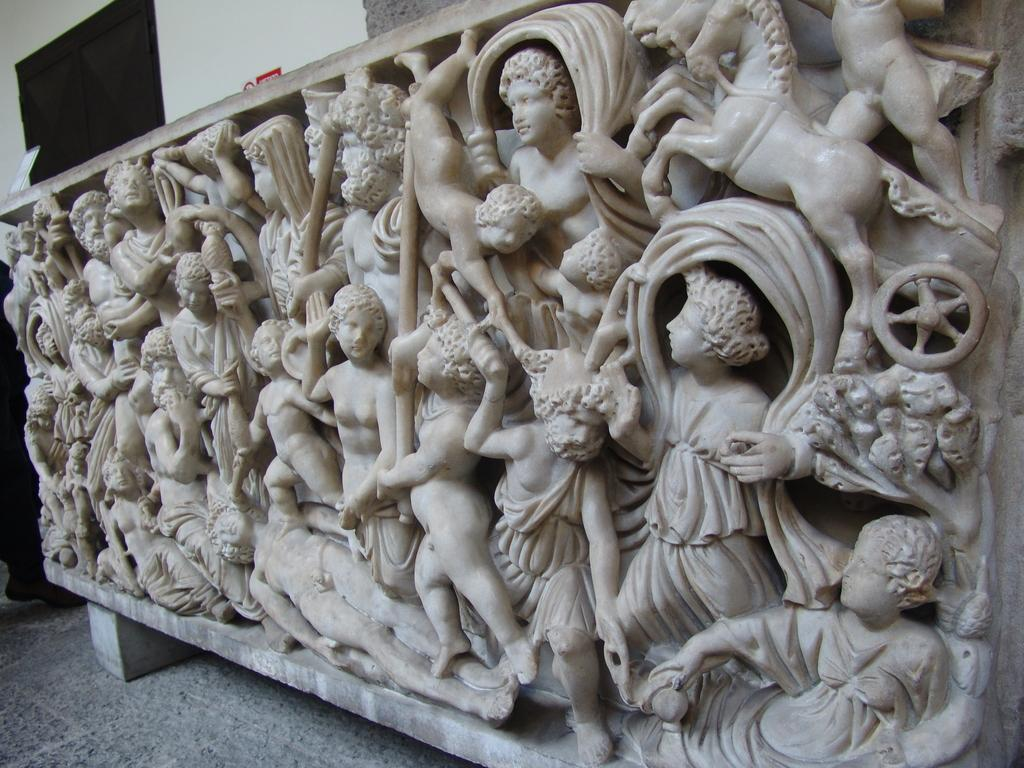What can be seen in the foreground of the image? There are sculptures in the foreground of the image. What do the sculptures seem to represent? The sculptures appear to represent a person. What is visible in the background of the image? There is a door in the background of the image. How many lizards are crawling on the sculptures in the image? There are no lizards present in the image; the sculptures represent a person. 